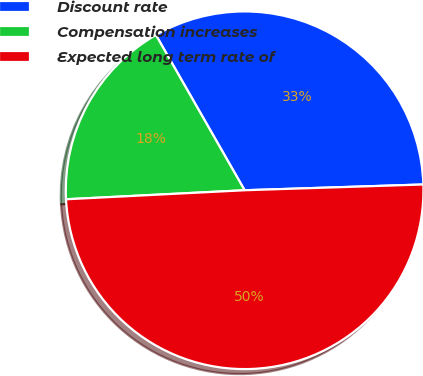<chart> <loc_0><loc_0><loc_500><loc_500><pie_chart><fcel>Discount rate<fcel>Compensation increases<fcel>Expected long term rate of<nl><fcel>32.75%<fcel>17.54%<fcel>49.71%<nl></chart> 